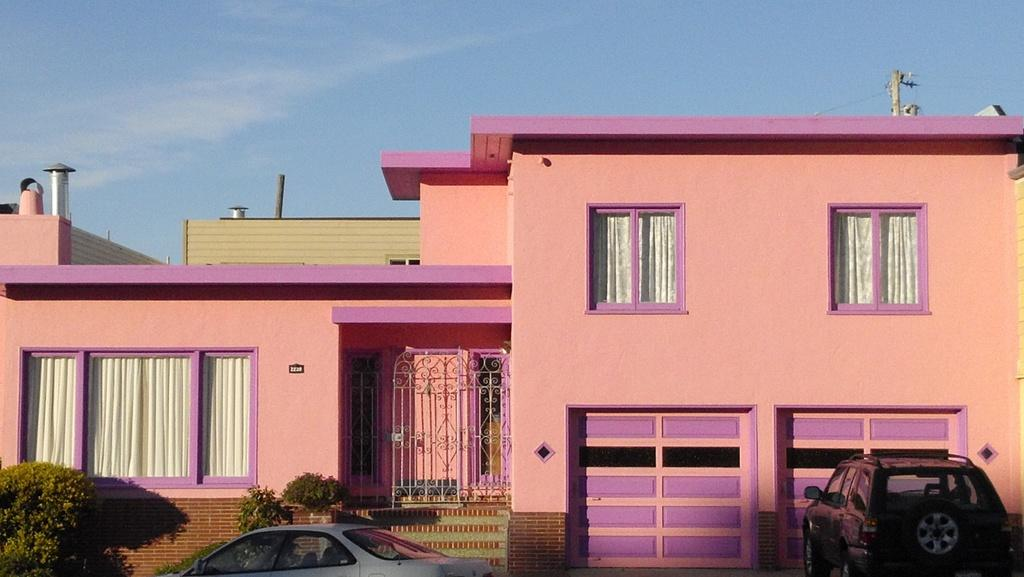What types of objects are present in the image? There are vehicles, small trees, a building, and poles in the image. Can you describe the trees in the background? The trees in the background are small and green. What is the color of the building in the image? The building is pink. What is the color of the sky in the image? The sky is blue. Is there a hat on top of the building in the image? There is no hat present on top of the building in the image. What book is the tree reading in the image? There are no trees reading books in the image, as trees are not capable of reading. How many screws can be seen on the vehicles in the image? There is no information about screws on the vehicles in the image, so it cannot be determined from the provided facts. 